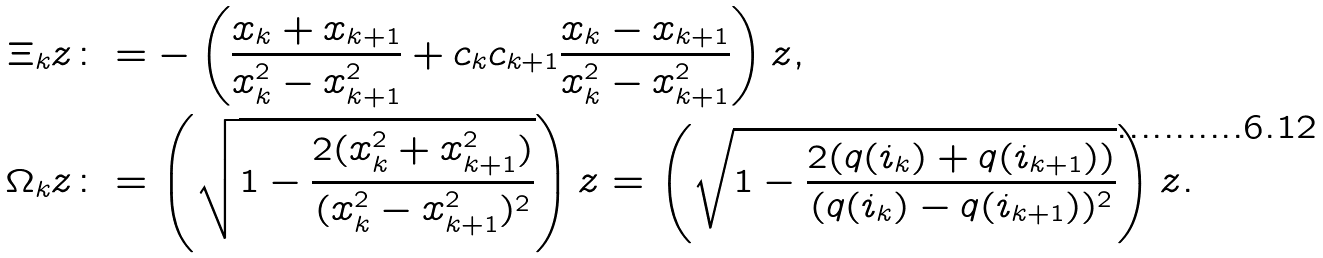Convert formula to latex. <formula><loc_0><loc_0><loc_500><loc_500>\Xi _ { k } z & \colon = - \left ( \frac { x _ { k } + x _ { k + 1 } } { x _ { k } ^ { 2 } - x _ { k + 1 } ^ { 2 } } + c _ { k } c _ { k + 1 } \frac { x _ { k } - x _ { k + 1 } } { x _ { k } ^ { 2 } - x _ { k + 1 } ^ { 2 } } \right ) z , \\ \Omega _ { k } z & \colon = \left ( \sqrt { 1 - \frac { 2 ( x _ { k } ^ { 2 } + x _ { k + 1 } ^ { 2 } ) } { ( x _ { k } ^ { 2 } - x _ { k + 1 } ^ { 2 } ) ^ { 2 } } } \right ) z = \left ( \sqrt { 1 - \frac { 2 ( q ( i _ { k } ) + q ( i _ { k + 1 } ) ) } { ( q ( i _ { k } ) - q ( i _ { k + 1 } ) ) ^ { 2 } } } \right ) z .</formula> 